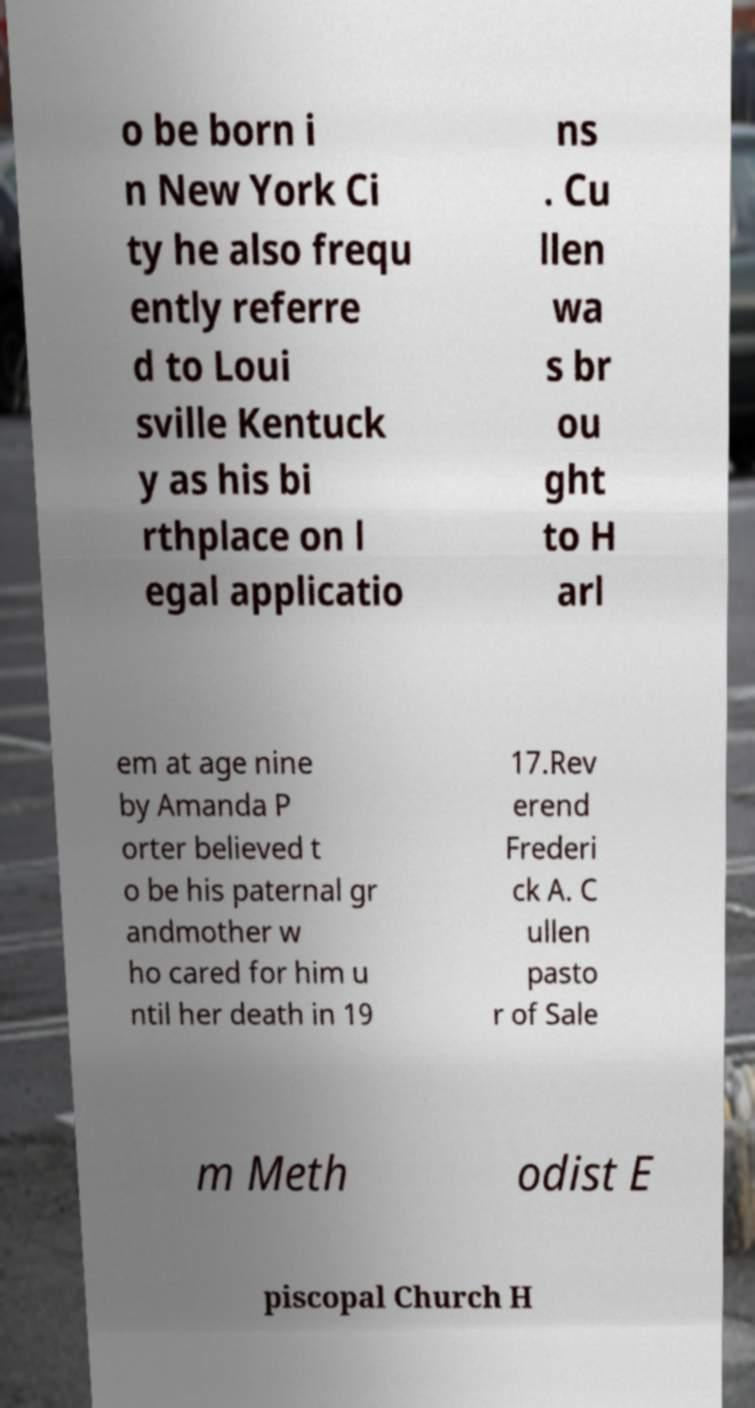Please identify and transcribe the text found in this image. o be born i n New York Ci ty he also frequ ently referre d to Loui sville Kentuck y as his bi rthplace on l egal applicatio ns . Cu llen wa s br ou ght to H arl em at age nine by Amanda P orter believed t o be his paternal gr andmother w ho cared for him u ntil her death in 19 17.Rev erend Frederi ck A. C ullen pasto r of Sale m Meth odist E piscopal Church H 